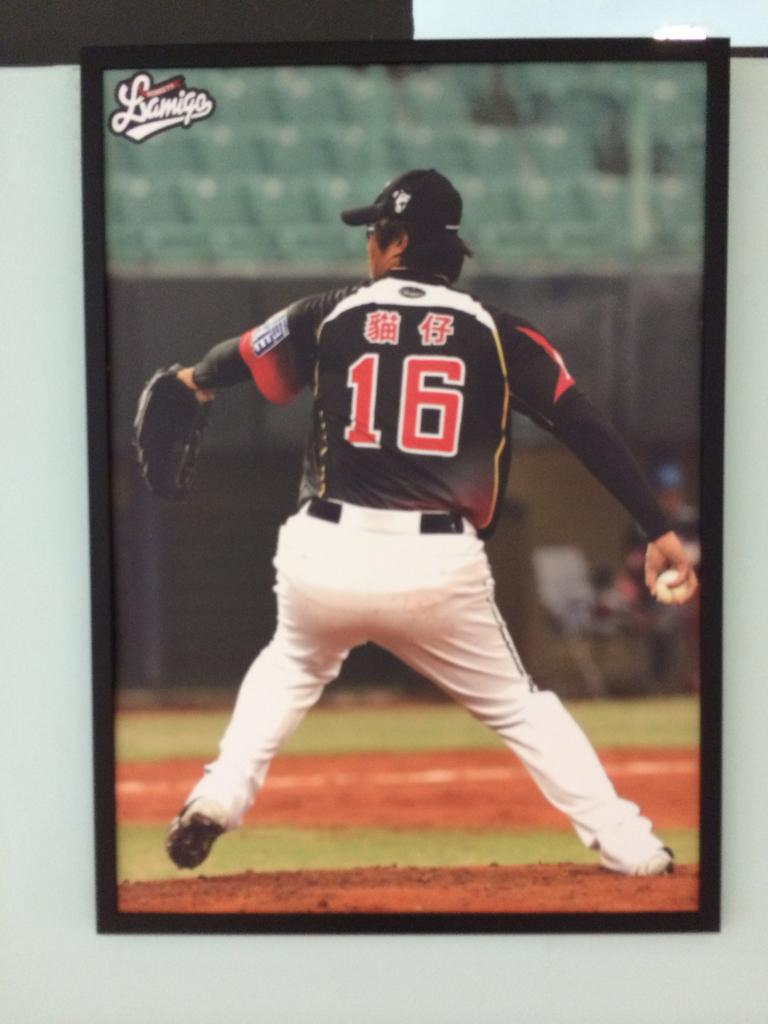<image>
Render a clear and concise summary of the photo. A photo of a Baseball Pitcher with the number 16 on his jersey. 